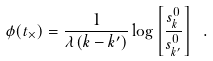Convert formula to latex. <formula><loc_0><loc_0><loc_500><loc_500>\phi ( t _ { \times } ) = \frac { 1 } { \lambda ( k - k ^ { \prime } ) } \log \left [ \frac { s _ { k } ^ { 0 } } { s _ { k ^ { \prime } } ^ { 0 } } \right ] \ .</formula> 